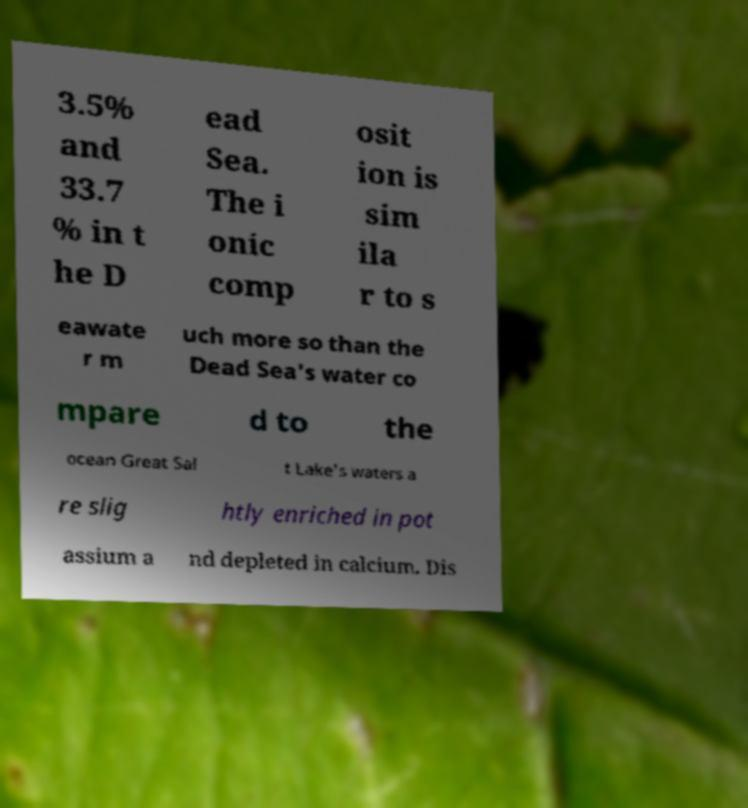Could you extract and type out the text from this image? 3.5% and 33.7 % in t he D ead Sea. The i onic comp osit ion is sim ila r to s eawate r m uch more so than the Dead Sea's water co mpare d to the ocean Great Sal t Lake's waters a re slig htly enriched in pot assium a nd depleted in calcium. Dis 